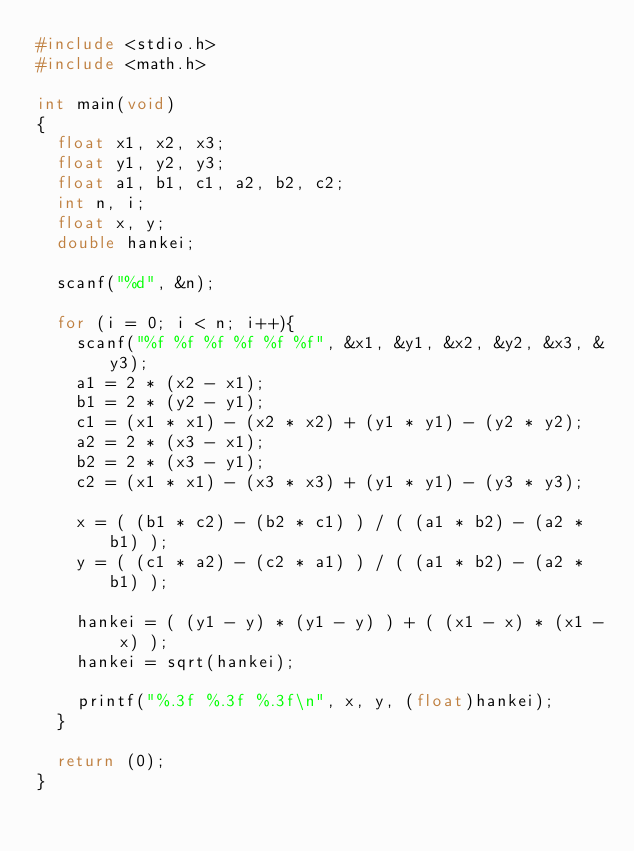<code> <loc_0><loc_0><loc_500><loc_500><_C_>#include <stdio.h>
#include <math.h>

int main(void)
{
	float x1, x2, x3;
	float y1, y2, y3;
	float a1, b1, c1, a2, b2, c2;
	int n, i;
	float x, y;
	double hankei;
	
	scanf("%d", &n);
	
	for (i = 0; i < n; i++){
		scanf("%f %f %f %f %f %f", &x1, &y1, &x2, &y2, &x3, &y3);
		a1 = 2 * (x2 - x1);
		b1 = 2 * (y2 - y1);
		c1 = (x1 * x1) - (x2 * x2) + (y1 * y1) - (y2 * y2);
		a2 = 2 * (x3 - x1);
		b2 = 2 * (x3 - y1);
		c2 = (x1 * x1) - (x3 * x3) + (y1 * y1) - (y3 * y3);
		
		x = ( (b1 * c2) - (b2 * c1) ) / ( (a1 * b2) - (a2 * b1) );
		y = ( (c1 * a2) - (c2 * a1) ) / ( (a1 * b2) - (a2 * b1) );
		
		hankei = ( (y1 - y) * (y1 - y) ) + ( (x1 - x) * (x1 - x) );
		hankei = sqrt(hankei);
		
		printf("%.3f %.3f %.3f\n", x, y, (float)hankei);
	}
	
	return (0);
}</code> 